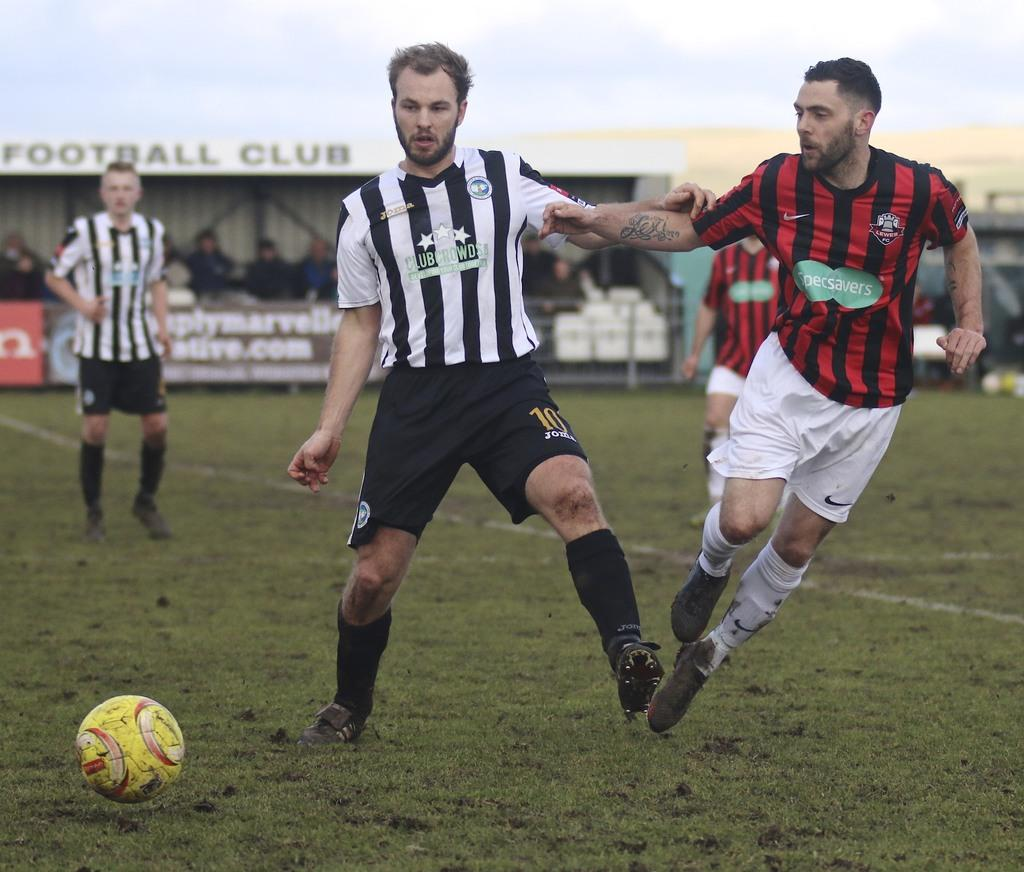What sport are the people playing in the image? The people are playing football in the image. What color is the ball used in the game? There is a yellow ball in the image. What colors are the t-shirts of the two people on one team? Two people are wearing black and white t-shirts. What colors are the t-shirts of the two people on the other team? Two people are wearing black and red t-shirts. Who is the creator of the camera that captured the image? The provided facts do not mention any information about the camera or its creator, so it cannot be determined from the image. 